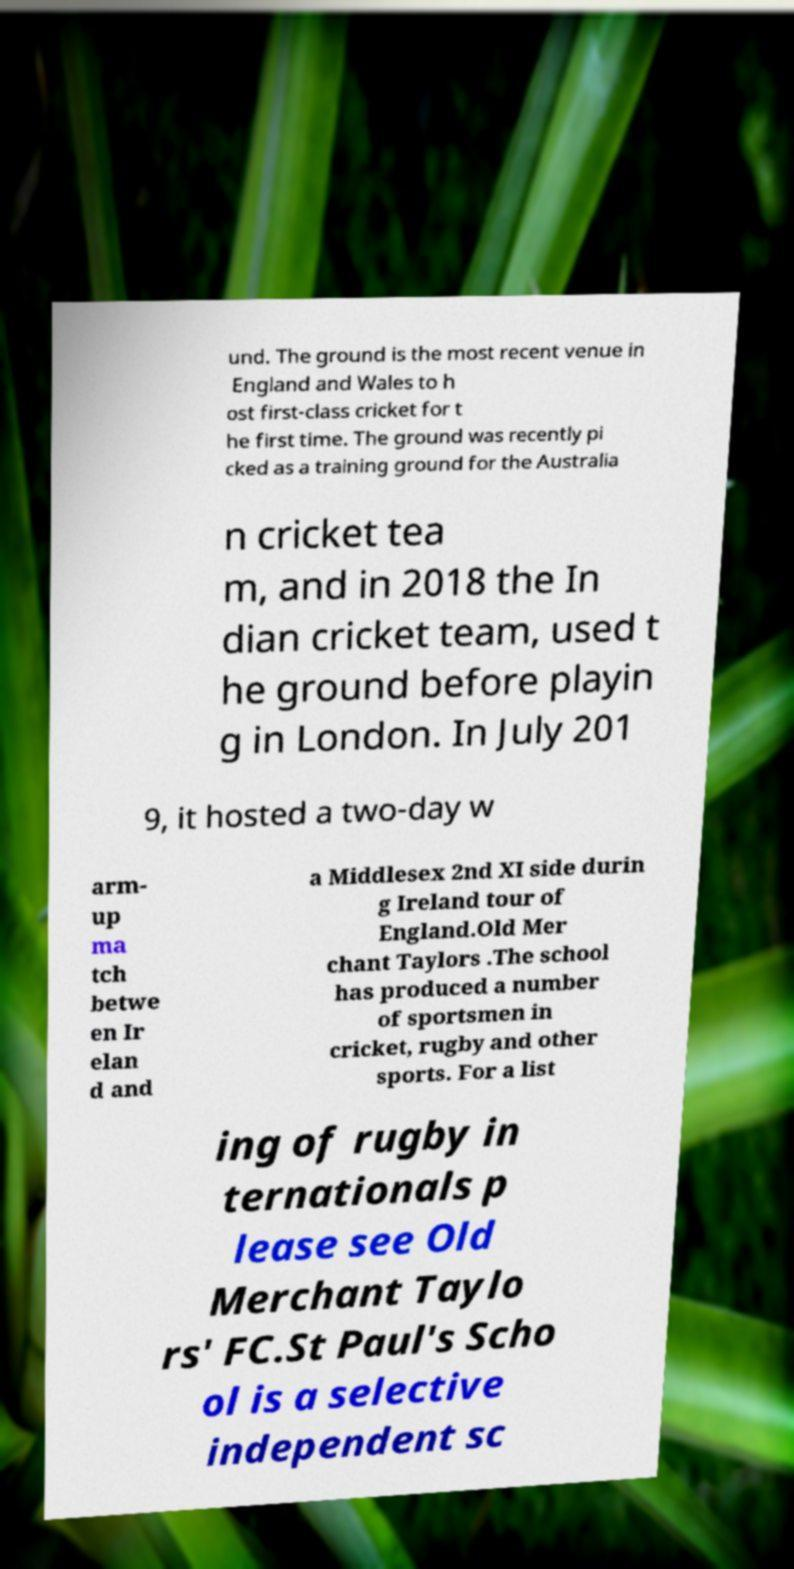There's text embedded in this image that I need extracted. Can you transcribe it verbatim? und. The ground is the most recent venue in England and Wales to h ost first-class cricket for t he first time. The ground was recently pi cked as a training ground for the Australia n cricket tea m, and in 2018 the In dian cricket team, used t he ground before playin g in London. In July 201 9, it hosted a two-day w arm- up ma tch betwe en Ir elan d and a Middlesex 2nd XI side durin g Ireland tour of England.Old Mer chant Taylors .The school has produced a number of sportsmen in cricket, rugby and other sports. For a list ing of rugby in ternationals p lease see Old Merchant Taylo rs' FC.St Paul's Scho ol is a selective independent sc 